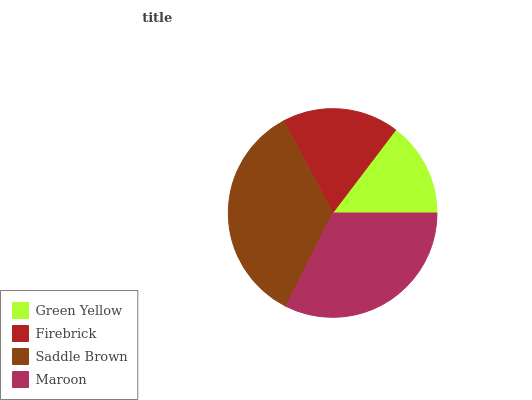Is Green Yellow the minimum?
Answer yes or no. Yes. Is Saddle Brown the maximum?
Answer yes or no. Yes. Is Firebrick the minimum?
Answer yes or no. No. Is Firebrick the maximum?
Answer yes or no. No. Is Firebrick greater than Green Yellow?
Answer yes or no. Yes. Is Green Yellow less than Firebrick?
Answer yes or no. Yes. Is Green Yellow greater than Firebrick?
Answer yes or no. No. Is Firebrick less than Green Yellow?
Answer yes or no. No. Is Maroon the high median?
Answer yes or no. Yes. Is Firebrick the low median?
Answer yes or no. Yes. Is Saddle Brown the high median?
Answer yes or no. No. Is Saddle Brown the low median?
Answer yes or no. No. 